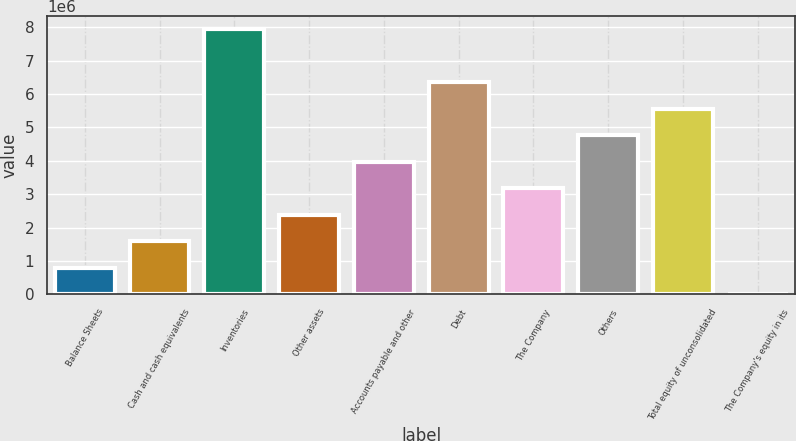<chart> <loc_0><loc_0><loc_500><loc_500><bar_chart><fcel>Balance Sheets<fcel>Cash and cash equivalents<fcel>Inventories<fcel>Other assets<fcel>Accounts payable and other<fcel>Debt<fcel>The Company<fcel>Others<fcel>Total equity of unconsolidated<fcel>The Company's equity in its<nl><fcel>794214<fcel>1.58839e+06<fcel>7.94184e+06<fcel>2.38257e+06<fcel>3.97093e+06<fcel>6.35347e+06<fcel>3.17675e+06<fcel>4.76511e+06<fcel>5.55929e+06<fcel>34<nl></chart> 